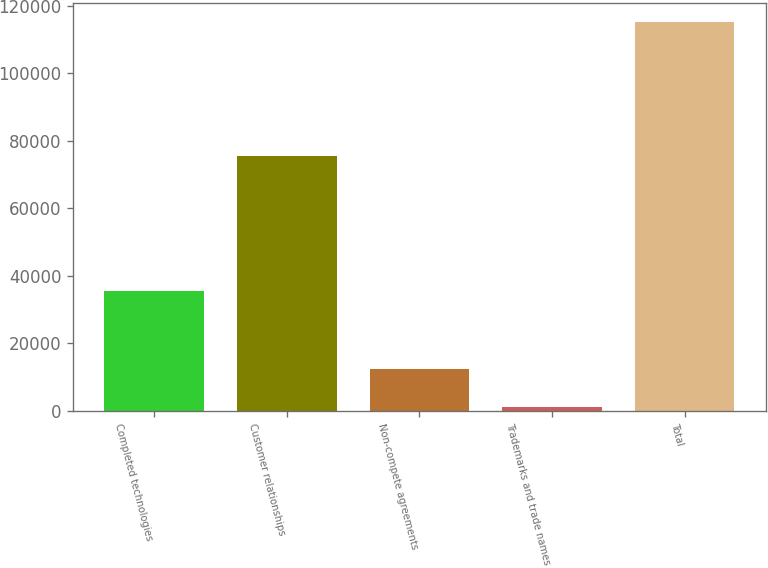Convert chart to OTSL. <chart><loc_0><loc_0><loc_500><loc_500><bar_chart><fcel>Completed technologies<fcel>Customer relationships<fcel>Non-compete agreements<fcel>Trademarks and trade names<fcel>Total<nl><fcel>35476<fcel>75563<fcel>12405.2<fcel>990<fcel>115142<nl></chart> 